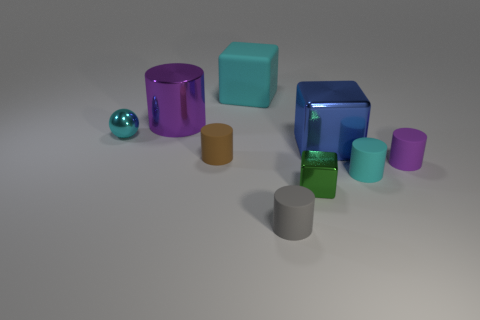If these objects were to be used in a physics lesson, which concept could they illustrate? These objects could serve as great tools for illustrating concepts of geometry, such as identifying different 3D shapes. They could also be used to explain properties of light, like reflection and refraction, or serve as examples in a discussion about materials and textures. Could they be used to demonstrate center of gravity? Absolutely. By observing and potentially manipulating these objects, students could learn about the center of gravity in various shapes and how it affects an object's stability and balance. 